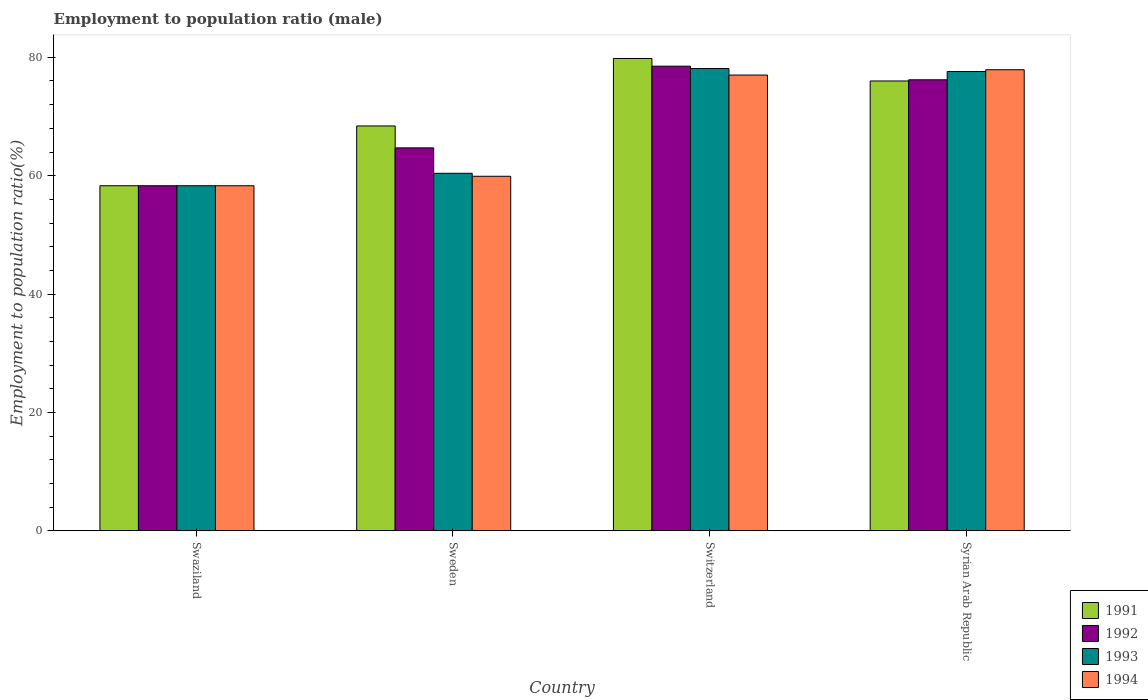How many different coloured bars are there?
Make the answer very short. 4. How many groups of bars are there?
Your answer should be compact. 4. Are the number of bars per tick equal to the number of legend labels?
Offer a terse response. Yes. How many bars are there on the 4th tick from the right?
Ensure brevity in your answer.  4. What is the label of the 4th group of bars from the left?
Offer a terse response. Syrian Arab Republic. In how many cases, is the number of bars for a given country not equal to the number of legend labels?
Keep it short and to the point. 0. What is the employment to population ratio in 1991 in Swaziland?
Your answer should be compact. 58.3. Across all countries, what is the maximum employment to population ratio in 1994?
Keep it short and to the point. 77.9. Across all countries, what is the minimum employment to population ratio in 1994?
Offer a terse response. 58.3. In which country was the employment to population ratio in 1994 maximum?
Your answer should be very brief. Syrian Arab Republic. In which country was the employment to population ratio in 1992 minimum?
Provide a short and direct response. Swaziland. What is the total employment to population ratio in 1991 in the graph?
Provide a short and direct response. 282.5. What is the difference between the employment to population ratio in 1993 in Sweden and that in Switzerland?
Your response must be concise. -17.7. What is the difference between the employment to population ratio in 1991 in Switzerland and the employment to population ratio in 1993 in Swaziland?
Provide a short and direct response. 21.5. What is the average employment to population ratio in 1992 per country?
Keep it short and to the point. 69.42. In how many countries, is the employment to population ratio in 1991 greater than 16 %?
Provide a short and direct response. 4. What is the ratio of the employment to population ratio in 1994 in Swaziland to that in Syrian Arab Republic?
Provide a succinct answer. 0.75. Is the employment to population ratio in 1993 in Swaziland less than that in Switzerland?
Provide a succinct answer. Yes. Is the difference between the employment to population ratio in 1992 in Sweden and Switzerland greater than the difference between the employment to population ratio in 1994 in Sweden and Switzerland?
Your response must be concise. Yes. What is the difference between the highest and the second highest employment to population ratio in 1994?
Ensure brevity in your answer.  -17.1. What is the difference between the highest and the lowest employment to population ratio in 1991?
Provide a succinct answer. 21.5. Is the sum of the employment to population ratio in 1993 in Swaziland and Switzerland greater than the maximum employment to population ratio in 1992 across all countries?
Make the answer very short. Yes. What does the 2nd bar from the left in Syrian Arab Republic represents?
Your answer should be compact. 1992. What does the 1st bar from the right in Sweden represents?
Give a very brief answer. 1994. Is it the case that in every country, the sum of the employment to population ratio in 1992 and employment to population ratio in 1993 is greater than the employment to population ratio in 1991?
Your answer should be compact. Yes. Are the values on the major ticks of Y-axis written in scientific E-notation?
Keep it short and to the point. No. Where does the legend appear in the graph?
Ensure brevity in your answer.  Bottom right. What is the title of the graph?
Your answer should be very brief. Employment to population ratio (male). Does "1984" appear as one of the legend labels in the graph?
Offer a very short reply. No. What is the label or title of the Y-axis?
Offer a terse response. Employment to population ratio(%). What is the Employment to population ratio(%) in 1991 in Swaziland?
Offer a very short reply. 58.3. What is the Employment to population ratio(%) of 1992 in Swaziland?
Your answer should be compact. 58.3. What is the Employment to population ratio(%) of 1993 in Swaziland?
Provide a succinct answer. 58.3. What is the Employment to population ratio(%) in 1994 in Swaziland?
Give a very brief answer. 58.3. What is the Employment to population ratio(%) in 1991 in Sweden?
Offer a terse response. 68.4. What is the Employment to population ratio(%) of 1992 in Sweden?
Provide a short and direct response. 64.7. What is the Employment to population ratio(%) in 1993 in Sweden?
Offer a terse response. 60.4. What is the Employment to population ratio(%) in 1994 in Sweden?
Make the answer very short. 59.9. What is the Employment to population ratio(%) in 1991 in Switzerland?
Give a very brief answer. 79.8. What is the Employment to population ratio(%) in 1992 in Switzerland?
Keep it short and to the point. 78.5. What is the Employment to population ratio(%) of 1993 in Switzerland?
Offer a very short reply. 78.1. What is the Employment to population ratio(%) of 1992 in Syrian Arab Republic?
Provide a succinct answer. 76.2. What is the Employment to population ratio(%) in 1993 in Syrian Arab Republic?
Your response must be concise. 77.6. What is the Employment to population ratio(%) of 1994 in Syrian Arab Republic?
Make the answer very short. 77.9. Across all countries, what is the maximum Employment to population ratio(%) in 1991?
Your response must be concise. 79.8. Across all countries, what is the maximum Employment to population ratio(%) in 1992?
Provide a succinct answer. 78.5. Across all countries, what is the maximum Employment to population ratio(%) of 1993?
Provide a short and direct response. 78.1. Across all countries, what is the maximum Employment to population ratio(%) in 1994?
Make the answer very short. 77.9. Across all countries, what is the minimum Employment to population ratio(%) of 1991?
Give a very brief answer. 58.3. Across all countries, what is the minimum Employment to population ratio(%) of 1992?
Your answer should be compact. 58.3. Across all countries, what is the minimum Employment to population ratio(%) in 1993?
Your response must be concise. 58.3. Across all countries, what is the minimum Employment to population ratio(%) of 1994?
Keep it short and to the point. 58.3. What is the total Employment to population ratio(%) of 1991 in the graph?
Your answer should be compact. 282.5. What is the total Employment to population ratio(%) in 1992 in the graph?
Provide a succinct answer. 277.7. What is the total Employment to population ratio(%) of 1993 in the graph?
Your response must be concise. 274.4. What is the total Employment to population ratio(%) of 1994 in the graph?
Your answer should be very brief. 273.1. What is the difference between the Employment to population ratio(%) of 1991 in Swaziland and that in Sweden?
Offer a very short reply. -10.1. What is the difference between the Employment to population ratio(%) of 1992 in Swaziland and that in Sweden?
Provide a short and direct response. -6.4. What is the difference between the Employment to population ratio(%) in 1994 in Swaziland and that in Sweden?
Keep it short and to the point. -1.6. What is the difference between the Employment to population ratio(%) of 1991 in Swaziland and that in Switzerland?
Your response must be concise. -21.5. What is the difference between the Employment to population ratio(%) in 1992 in Swaziland and that in Switzerland?
Offer a very short reply. -20.2. What is the difference between the Employment to population ratio(%) in 1993 in Swaziland and that in Switzerland?
Offer a very short reply. -19.8. What is the difference between the Employment to population ratio(%) in 1994 in Swaziland and that in Switzerland?
Provide a short and direct response. -18.7. What is the difference between the Employment to population ratio(%) of 1991 in Swaziland and that in Syrian Arab Republic?
Give a very brief answer. -17.7. What is the difference between the Employment to population ratio(%) of 1992 in Swaziland and that in Syrian Arab Republic?
Give a very brief answer. -17.9. What is the difference between the Employment to population ratio(%) of 1993 in Swaziland and that in Syrian Arab Republic?
Your response must be concise. -19.3. What is the difference between the Employment to population ratio(%) in 1994 in Swaziland and that in Syrian Arab Republic?
Offer a very short reply. -19.6. What is the difference between the Employment to population ratio(%) of 1993 in Sweden and that in Switzerland?
Your response must be concise. -17.7. What is the difference between the Employment to population ratio(%) in 1994 in Sweden and that in Switzerland?
Offer a terse response. -17.1. What is the difference between the Employment to population ratio(%) of 1991 in Sweden and that in Syrian Arab Republic?
Provide a succinct answer. -7.6. What is the difference between the Employment to population ratio(%) in 1993 in Sweden and that in Syrian Arab Republic?
Give a very brief answer. -17.2. What is the difference between the Employment to population ratio(%) in 1991 in Switzerland and that in Syrian Arab Republic?
Offer a very short reply. 3.8. What is the difference between the Employment to population ratio(%) in 1993 in Switzerland and that in Syrian Arab Republic?
Offer a very short reply. 0.5. What is the difference between the Employment to population ratio(%) of 1994 in Switzerland and that in Syrian Arab Republic?
Your answer should be compact. -0.9. What is the difference between the Employment to population ratio(%) of 1991 in Swaziland and the Employment to population ratio(%) of 1993 in Sweden?
Keep it short and to the point. -2.1. What is the difference between the Employment to population ratio(%) of 1991 in Swaziland and the Employment to population ratio(%) of 1994 in Sweden?
Provide a short and direct response. -1.6. What is the difference between the Employment to population ratio(%) in 1992 in Swaziland and the Employment to population ratio(%) in 1994 in Sweden?
Ensure brevity in your answer.  -1.6. What is the difference between the Employment to population ratio(%) in 1991 in Swaziland and the Employment to population ratio(%) in 1992 in Switzerland?
Your response must be concise. -20.2. What is the difference between the Employment to population ratio(%) in 1991 in Swaziland and the Employment to population ratio(%) in 1993 in Switzerland?
Keep it short and to the point. -19.8. What is the difference between the Employment to population ratio(%) of 1991 in Swaziland and the Employment to population ratio(%) of 1994 in Switzerland?
Offer a very short reply. -18.7. What is the difference between the Employment to population ratio(%) of 1992 in Swaziland and the Employment to population ratio(%) of 1993 in Switzerland?
Ensure brevity in your answer.  -19.8. What is the difference between the Employment to population ratio(%) of 1992 in Swaziland and the Employment to population ratio(%) of 1994 in Switzerland?
Provide a succinct answer. -18.7. What is the difference between the Employment to population ratio(%) in 1993 in Swaziland and the Employment to population ratio(%) in 1994 in Switzerland?
Provide a short and direct response. -18.7. What is the difference between the Employment to population ratio(%) in 1991 in Swaziland and the Employment to population ratio(%) in 1992 in Syrian Arab Republic?
Offer a terse response. -17.9. What is the difference between the Employment to population ratio(%) of 1991 in Swaziland and the Employment to population ratio(%) of 1993 in Syrian Arab Republic?
Offer a very short reply. -19.3. What is the difference between the Employment to population ratio(%) of 1991 in Swaziland and the Employment to population ratio(%) of 1994 in Syrian Arab Republic?
Provide a short and direct response. -19.6. What is the difference between the Employment to population ratio(%) of 1992 in Swaziland and the Employment to population ratio(%) of 1993 in Syrian Arab Republic?
Offer a terse response. -19.3. What is the difference between the Employment to population ratio(%) in 1992 in Swaziland and the Employment to population ratio(%) in 1994 in Syrian Arab Republic?
Make the answer very short. -19.6. What is the difference between the Employment to population ratio(%) of 1993 in Swaziland and the Employment to population ratio(%) of 1994 in Syrian Arab Republic?
Provide a succinct answer. -19.6. What is the difference between the Employment to population ratio(%) of 1992 in Sweden and the Employment to population ratio(%) of 1993 in Switzerland?
Give a very brief answer. -13.4. What is the difference between the Employment to population ratio(%) of 1992 in Sweden and the Employment to population ratio(%) of 1994 in Switzerland?
Ensure brevity in your answer.  -12.3. What is the difference between the Employment to population ratio(%) in 1993 in Sweden and the Employment to population ratio(%) in 1994 in Switzerland?
Ensure brevity in your answer.  -16.6. What is the difference between the Employment to population ratio(%) of 1991 in Sweden and the Employment to population ratio(%) of 1992 in Syrian Arab Republic?
Your answer should be compact. -7.8. What is the difference between the Employment to population ratio(%) in 1991 in Sweden and the Employment to population ratio(%) in 1993 in Syrian Arab Republic?
Offer a terse response. -9.2. What is the difference between the Employment to population ratio(%) in 1991 in Sweden and the Employment to population ratio(%) in 1994 in Syrian Arab Republic?
Provide a short and direct response. -9.5. What is the difference between the Employment to population ratio(%) of 1993 in Sweden and the Employment to population ratio(%) of 1994 in Syrian Arab Republic?
Provide a succinct answer. -17.5. What is the difference between the Employment to population ratio(%) of 1991 in Switzerland and the Employment to population ratio(%) of 1992 in Syrian Arab Republic?
Give a very brief answer. 3.6. What is the difference between the Employment to population ratio(%) in 1991 in Switzerland and the Employment to population ratio(%) in 1994 in Syrian Arab Republic?
Offer a very short reply. 1.9. What is the difference between the Employment to population ratio(%) of 1992 in Switzerland and the Employment to population ratio(%) of 1994 in Syrian Arab Republic?
Give a very brief answer. 0.6. What is the average Employment to population ratio(%) in 1991 per country?
Keep it short and to the point. 70.62. What is the average Employment to population ratio(%) in 1992 per country?
Your response must be concise. 69.42. What is the average Employment to population ratio(%) of 1993 per country?
Ensure brevity in your answer.  68.6. What is the average Employment to population ratio(%) in 1994 per country?
Your answer should be very brief. 68.28. What is the difference between the Employment to population ratio(%) of 1992 and Employment to population ratio(%) of 1993 in Swaziland?
Your answer should be very brief. 0. What is the difference between the Employment to population ratio(%) in 1992 and Employment to population ratio(%) in 1994 in Swaziland?
Your answer should be very brief. 0. What is the difference between the Employment to population ratio(%) of 1993 and Employment to population ratio(%) of 1994 in Swaziland?
Offer a very short reply. 0. What is the difference between the Employment to population ratio(%) of 1991 and Employment to population ratio(%) of 1992 in Sweden?
Ensure brevity in your answer.  3.7. What is the difference between the Employment to population ratio(%) in 1992 and Employment to population ratio(%) in 1993 in Sweden?
Keep it short and to the point. 4.3. What is the difference between the Employment to population ratio(%) in 1993 and Employment to population ratio(%) in 1994 in Switzerland?
Ensure brevity in your answer.  1.1. What is the difference between the Employment to population ratio(%) in 1991 and Employment to population ratio(%) in 1992 in Syrian Arab Republic?
Offer a very short reply. -0.2. What is the difference between the Employment to population ratio(%) in 1991 and Employment to population ratio(%) in 1993 in Syrian Arab Republic?
Ensure brevity in your answer.  -1.6. What is the difference between the Employment to population ratio(%) in 1992 and Employment to population ratio(%) in 1993 in Syrian Arab Republic?
Give a very brief answer. -1.4. What is the ratio of the Employment to population ratio(%) in 1991 in Swaziland to that in Sweden?
Give a very brief answer. 0.85. What is the ratio of the Employment to population ratio(%) of 1992 in Swaziland to that in Sweden?
Ensure brevity in your answer.  0.9. What is the ratio of the Employment to population ratio(%) of 1993 in Swaziland to that in Sweden?
Your answer should be compact. 0.97. What is the ratio of the Employment to population ratio(%) of 1994 in Swaziland to that in Sweden?
Your response must be concise. 0.97. What is the ratio of the Employment to population ratio(%) in 1991 in Swaziland to that in Switzerland?
Ensure brevity in your answer.  0.73. What is the ratio of the Employment to population ratio(%) in 1992 in Swaziland to that in Switzerland?
Offer a very short reply. 0.74. What is the ratio of the Employment to population ratio(%) of 1993 in Swaziland to that in Switzerland?
Your response must be concise. 0.75. What is the ratio of the Employment to population ratio(%) in 1994 in Swaziland to that in Switzerland?
Your response must be concise. 0.76. What is the ratio of the Employment to population ratio(%) in 1991 in Swaziland to that in Syrian Arab Republic?
Offer a very short reply. 0.77. What is the ratio of the Employment to population ratio(%) in 1992 in Swaziland to that in Syrian Arab Republic?
Your answer should be compact. 0.77. What is the ratio of the Employment to population ratio(%) of 1993 in Swaziland to that in Syrian Arab Republic?
Your answer should be very brief. 0.75. What is the ratio of the Employment to population ratio(%) of 1994 in Swaziland to that in Syrian Arab Republic?
Your answer should be compact. 0.75. What is the ratio of the Employment to population ratio(%) in 1992 in Sweden to that in Switzerland?
Provide a succinct answer. 0.82. What is the ratio of the Employment to population ratio(%) in 1993 in Sweden to that in Switzerland?
Offer a terse response. 0.77. What is the ratio of the Employment to population ratio(%) of 1994 in Sweden to that in Switzerland?
Give a very brief answer. 0.78. What is the ratio of the Employment to population ratio(%) of 1991 in Sweden to that in Syrian Arab Republic?
Provide a short and direct response. 0.9. What is the ratio of the Employment to population ratio(%) in 1992 in Sweden to that in Syrian Arab Republic?
Keep it short and to the point. 0.85. What is the ratio of the Employment to population ratio(%) of 1993 in Sweden to that in Syrian Arab Republic?
Your response must be concise. 0.78. What is the ratio of the Employment to population ratio(%) in 1994 in Sweden to that in Syrian Arab Republic?
Your answer should be compact. 0.77. What is the ratio of the Employment to population ratio(%) of 1992 in Switzerland to that in Syrian Arab Republic?
Give a very brief answer. 1.03. What is the ratio of the Employment to population ratio(%) in 1993 in Switzerland to that in Syrian Arab Republic?
Your answer should be very brief. 1.01. What is the ratio of the Employment to population ratio(%) in 1994 in Switzerland to that in Syrian Arab Republic?
Provide a succinct answer. 0.99. What is the difference between the highest and the second highest Employment to population ratio(%) in 1992?
Provide a succinct answer. 2.3. What is the difference between the highest and the lowest Employment to population ratio(%) in 1991?
Give a very brief answer. 21.5. What is the difference between the highest and the lowest Employment to population ratio(%) in 1992?
Your answer should be compact. 20.2. What is the difference between the highest and the lowest Employment to population ratio(%) in 1993?
Your response must be concise. 19.8. What is the difference between the highest and the lowest Employment to population ratio(%) in 1994?
Your response must be concise. 19.6. 